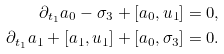<formula> <loc_0><loc_0><loc_500><loc_500>\partial _ { t _ { 1 } } a _ { 0 } - \sigma _ { 3 } + [ a _ { 0 } , u _ { 1 } ] & = 0 , \\ \partial _ { t _ { 1 } } a _ { 1 } + [ a _ { 1 } , u _ { 1 } ] + [ a _ { 0 } , \sigma _ { 3 } ] & = 0 .</formula> 